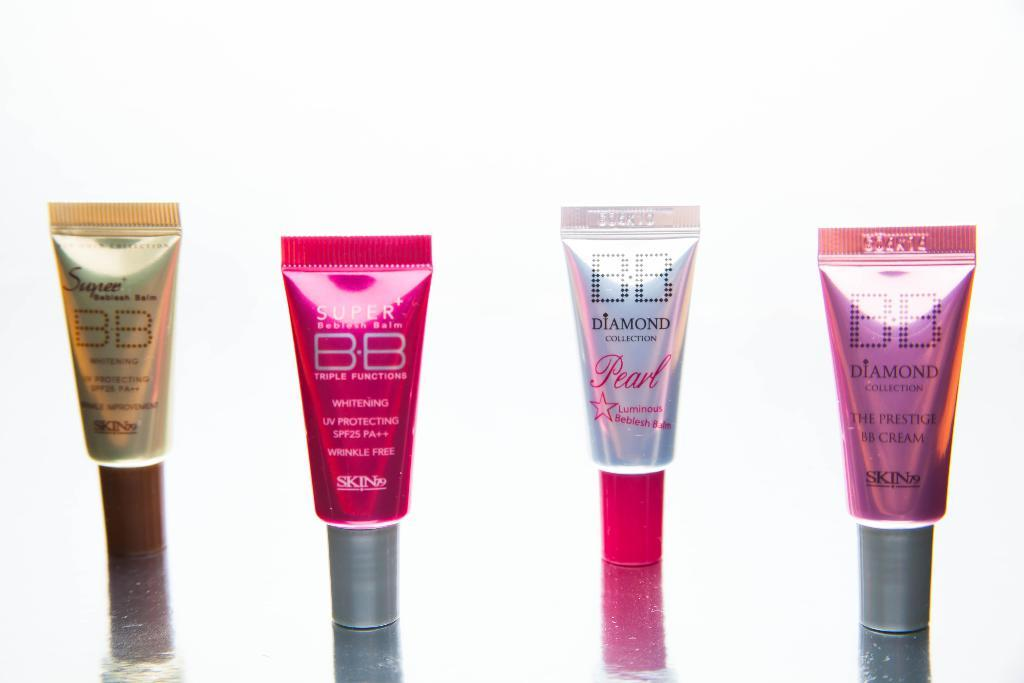<image>
Write a terse but informative summary of the picture. Four different bottles of BB Diamond beside each other 